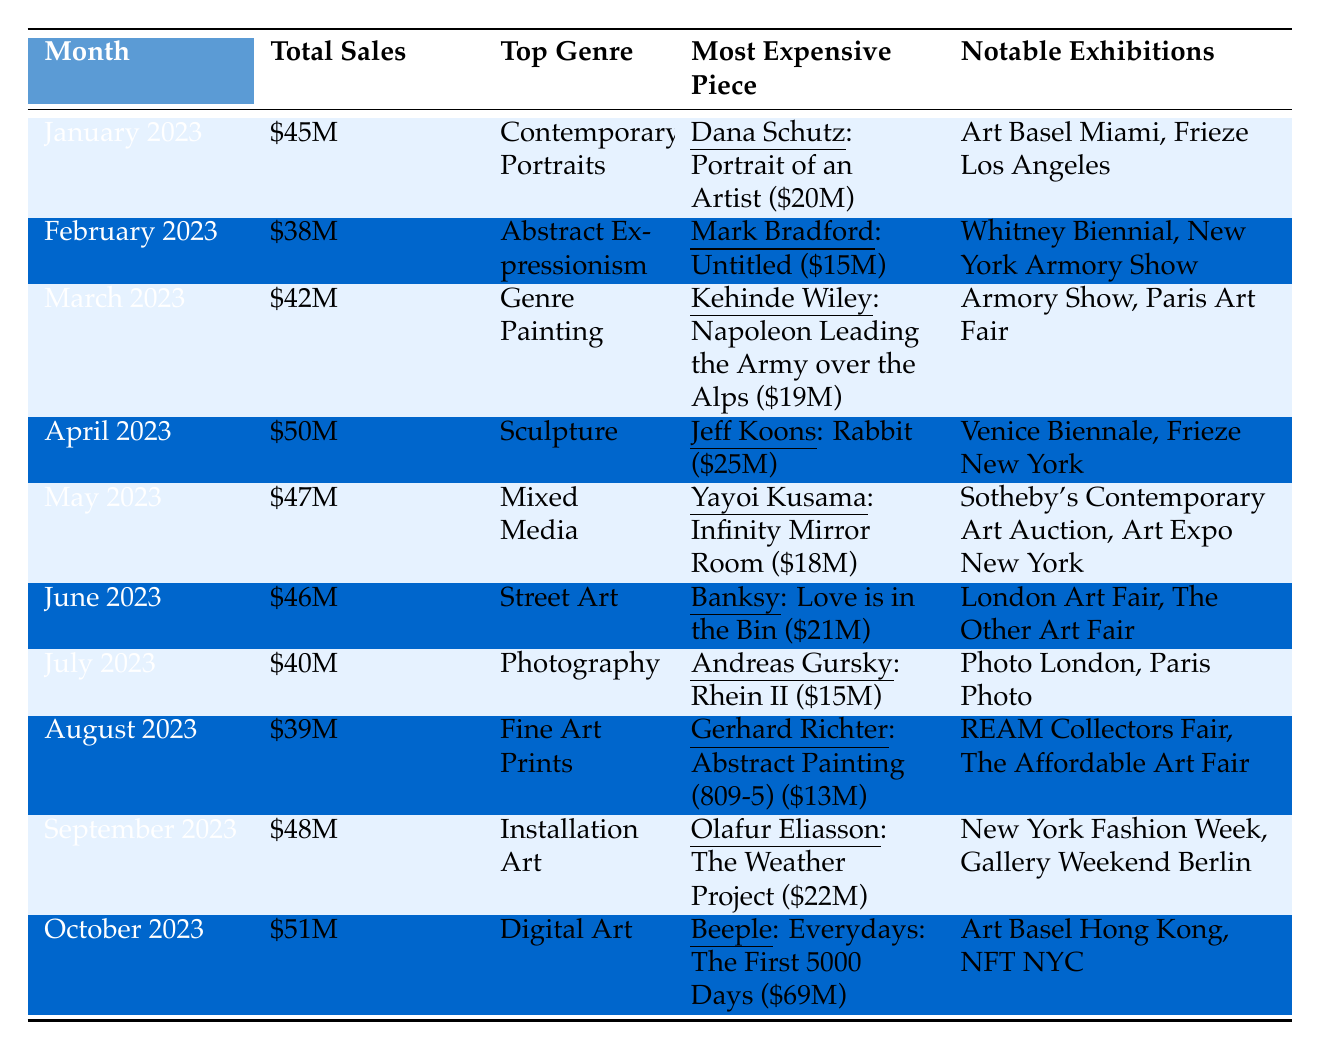What was the total sales in April 2023? The total sales for April 2023 is given directly in the table as \$50 million.
Answer: \$50 million Which genre had the highest sales in January 2023? In January 2023, the top genre is listed as "Contemporary Portraits".
Answer: Contemporary Portraits Who was the artist of the most expensive piece sold in October 2023? The most expensive piece in October 2023 was by the artist "Beeple".
Answer: Beeple What is the difference in total sales between May 2023 and July 2023? Total sales in May 2023 is \$47 million and in July 2023 is \$40 million. The difference is calculated as \$47 million - \$40 million = \$7 million.
Answer: \$7 million Which artist had a more expensive piece sold: Kehinde Wiley or Jeff Koons? Kehinde Wiley’s most expensive piece sold for \$19 million and Jeff Koons’ piece sold for \$25 million. Since \$25 million is greater than \$19 million, Jeff Koons had the more expensive piece.
Answer: Jeff Koons How many notable exhibitions were listed for June 2023? The table shows two exhibitions listed for June 2023: "London Art Fair" and "The Other Art Fair". Thus, the total count is 2.
Answer: 2 What was the average total sales from January to March 2023? The total sales for January, February, and March are \$45 million, \$38 million, and \$42 million respectively. Sum these figures: \$45M + \$38M + \$42M = \$125 million. Divide by 3 months for the average: \$125 million / 3 = approximately \$41.67 million.
Answer: \$41.67 million Was the total sales in September 2023 higher than in August 2023? The total sales for September 2023 is \$48 million and for August 2023 is \$39 million. Since \$48 million is greater than \$39 million, the total sales in September was higher.
Answer: Yes What is the most expensive piece sold between January and September 2023? The most expensive piece until September 2023 is identified: Dana Schutz at \$20 million, Mark Bradford at \$15 million, Kehinde Wiley at \$19 million, Jeff Koons at \$25 million, Yayoi Kusama at \$18 million, Banksy at \$21 million, Andreas Gursky at \$15 million, Gerhard Richter at \$13 million, and Olafur Eliasson at \$22 million. The highest among these is Jeff Koons' piece at \$25 million.
Answer: \$25 million Which month had the lowest total sales in the given data? Looking at all total sales figures, February 2023 has the lowest at \$38 million.
Answer: February 2023 